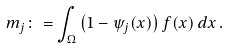Convert formula to latex. <formula><loc_0><loc_0><loc_500><loc_500>m _ { j } \colon = \int _ { \Omega } \left ( 1 - \psi _ { j } ( x ) \right ) f ( x ) \, d x \, .</formula> 